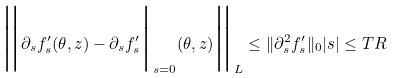Convert formula to latex. <formula><loc_0><loc_0><loc_500><loc_500>\Big \| \partial _ { s } f ^ { \prime } _ { s } ( \theta , z ) - \partial _ { s } f ^ { \prime } _ { s } \Big | _ { s = 0 } ( \theta , z ) \Big \| _ { \L L } \leq \| \partial ^ { 2 } _ { s } f ^ { \prime } _ { s } \| _ { 0 } | s | \leq T R</formula> 